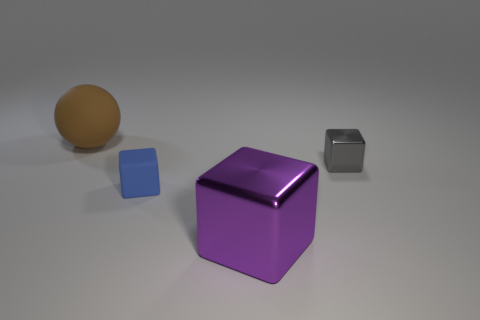Add 4 big purple rubber objects. How many objects exist? 8 Subtract all balls. How many objects are left? 3 Subtract all red objects. Subtract all small blue rubber objects. How many objects are left? 3 Add 3 large brown things. How many large brown things are left? 4 Add 2 rubber blocks. How many rubber blocks exist? 3 Subtract 0 green cubes. How many objects are left? 4 